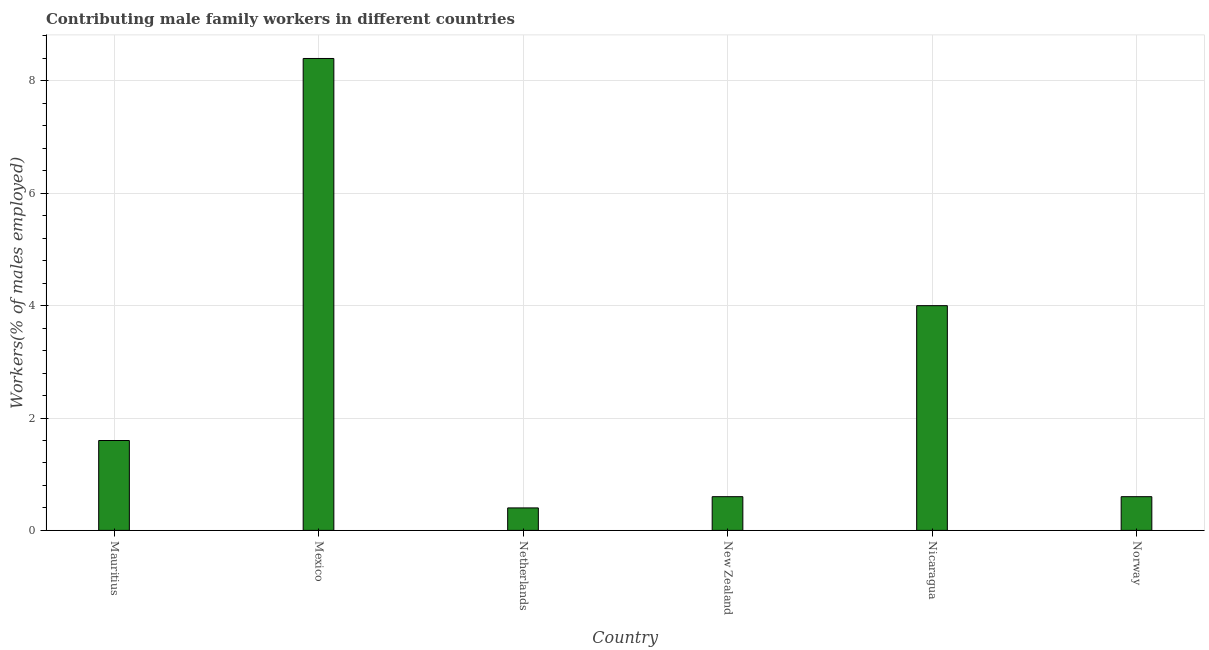Does the graph contain grids?
Ensure brevity in your answer.  Yes. What is the title of the graph?
Give a very brief answer. Contributing male family workers in different countries. What is the label or title of the X-axis?
Offer a terse response. Country. What is the label or title of the Y-axis?
Make the answer very short. Workers(% of males employed). What is the contributing male family workers in Norway?
Offer a terse response. 0.6. Across all countries, what is the maximum contributing male family workers?
Your response must be concise. 8.4. Across all countries, what is the minimum contributing male family workers?
Provide a short and direct response. 0.4. What is the sum of the contributing male family workers?
Ensure brevity in your answer.  15.6. What is the average contributing male family workers per country?
Your answer should be very brief. 2.6. What is the median contributing male family workers?
Offer a very short reply. 1.1. What is the ratio of the contributing male family workers in Netherlands to that in New Zealand?
Provide a succinct answer. 0.67. Is the contributing male family workers in Netherlands less than that in Norway?
Ensure brevity in your answer.  Yes. Is the difference between the contributing male family workers in Mauritius and Mexico greater than the difference between any two countries?
Offer a terse response. No. What is the difference between the highest and the lowest contributing male family workers?
Provide a short and direct response. 8. In how many countries, is the contributing male family workers greater than the average contributing male family workers taken over all countries?
Offer a very short reply. 2. How many countries are there in the graph?
Keep it short and to the point. 6. What is the Workers(% of males employed) in Mauritius?
Your answer should be very brief. 1.6. What is the Workers(% of males employed) of Mexico?
Your response must be concise. 8.4. What is the Workers(% of males employed) in Netherlands?
Make the answer very short. 0.4. What is the Workers(% of males employed) in New Zealand?
Your answer should be very brief. 0.6. What is the Workers(% of males employed) in Nicaragua?
Your response must be concise. 4. What is the Workers(% of males employed) of Norway?
Ensure brevity in your answer.  0.6. What is the difference between the Workers(% of males employed) in Mauritius and Mexico?
Your answer should be compact. -6.8. What is the difference between the Workers(% of males employed) in Mauritius and Netherlands?
Your answer should be very brief. 1.2. What is the difference between the Workers(% of males employed) in Mauritius and New Zealand?
Provide a short and direct response. 1. What is the difference between the Workers(% of males employed) in Mauritius and Nicaragua?
Your answer should be compact. -2.4. What is the difference between the Workers(% of males employed) in Mexico and Norway?
Make the answer very short. 7.8. What is the difference between the Workers(% of males employed) in Netherlands and New Zealand?
Your answer should be very brief. -0.2. What is the difference between the Workers(% of males employed) in Netherlands and Nicaragua?
Give a very brief answer. -3.6. What is the ratio of the Workers(% of males employed) in Mauritius to that in Mexico?
Your answer should be very brief. 0.19. What is the ratio of the Workers(% of males employed) in Mauritius to that in New Zealand?
Your answer should be very brief. 2.67. What is the ratio of the Workers(% of males employed) in Mauritius to that in Norway?
Offer a very short reply. 2.67. What is the ratio of the Workers(% of males employed) in Mexico to that in Netherlands?
Your response must be concise. 21. What is the ratio of the Workers(% of males employed) in Mexico to that in Nicaragua?
Offer a very short reply. 2.1. What is the ratio of the Workers(% of males employed) in Mexico to that in Norway?
Offer a very short reply. 14. What is the ratio of the Workers(% of males employed) in Netherlands to that in New Zealand?
Your response must be concise. 0.67. What is the ratio of the Workers(% of males employed) in Netherlands to that in Norway?
Keep it short and to the point. 0.67. What is the ratio of the Workers(% of males employed) in New Zealand to that in Nicaragua?
Ensure brevity in your answer.  0.15. What is the ratio of the Workers(% of males employed) in Nicaragua to that in Norway?
Provide a succinct answer. 6.67. 